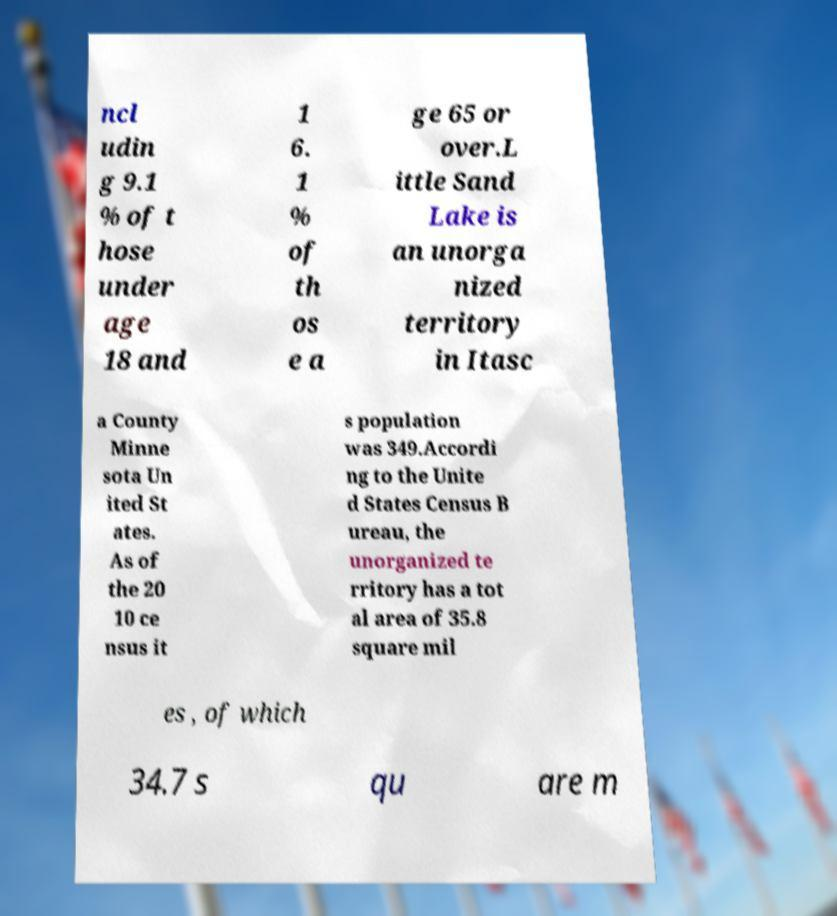Could you extract and type out the text from this image? ncl udin g 9.1 % of t hose under age 18 and 1 6. 1 % of th os e a ge 65 or over.L ittle Sand Lake is an unorga nized territory in Itasc a County Minne sota Un ited St ates. As of the 20 10 ce nsus it s population was 349.Accordi ng to the Unite d States Census B ureau, the unorganized te rritory has a tot al area of 35.8 square mil es , of which 34.7 s qu are m 